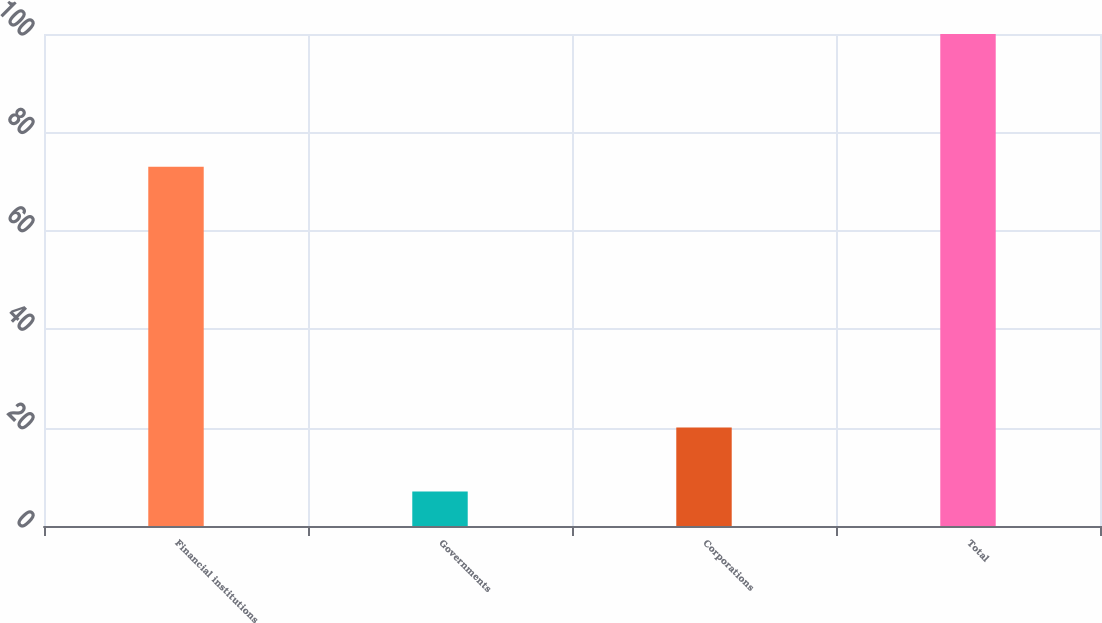Convert chart. <chart><loc_0><loc_0><loc_500><loc_500><bar_chart><fcel>Financial institutions<fcel>Governments<fcel>Corporations<fcel>Total<nl><fcel>73<fcel>7<fcel>20<fcel>100<nl></chart> 